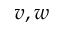Convert formula to latex. <formula><loc_0><loc_0><loc_500><loc_500>v , w</formula> 